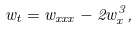<formula> <loc_0><loc_0><loc_500><loc_500>w _ { t } = w _ { x x x } - 2 w _ { x } ^ { 3 } ,</formula> 